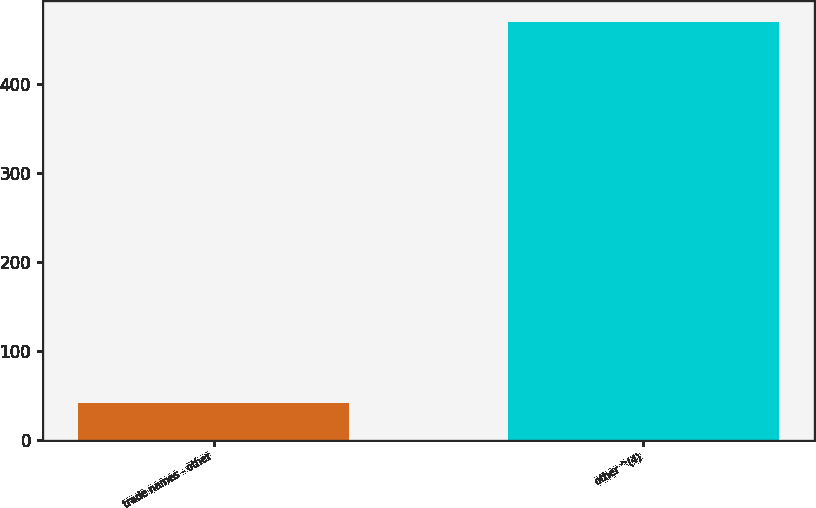Convert chart. <chart><loc_0><loc_0><loc_500><loc_500><bar_chart><fcel>trade names - other<fcel>other ^(4)<nl><fcel>41.6<fcel>469.6<nl></chart> 